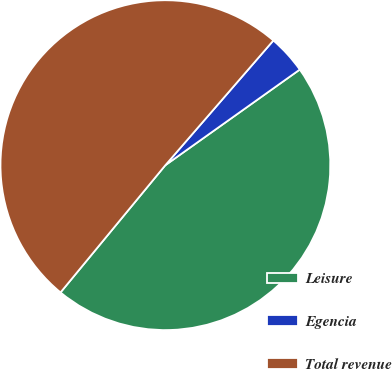Convert chart. <chart><loc_0><loc_0><loc_500><loc_500><pie_chart><fcel>Leisure<fcel>Egencia<fcel>Total revenue<nl><fcel>45.81%<fcel>3.8%<fcel>50.39%<nl></chart> 